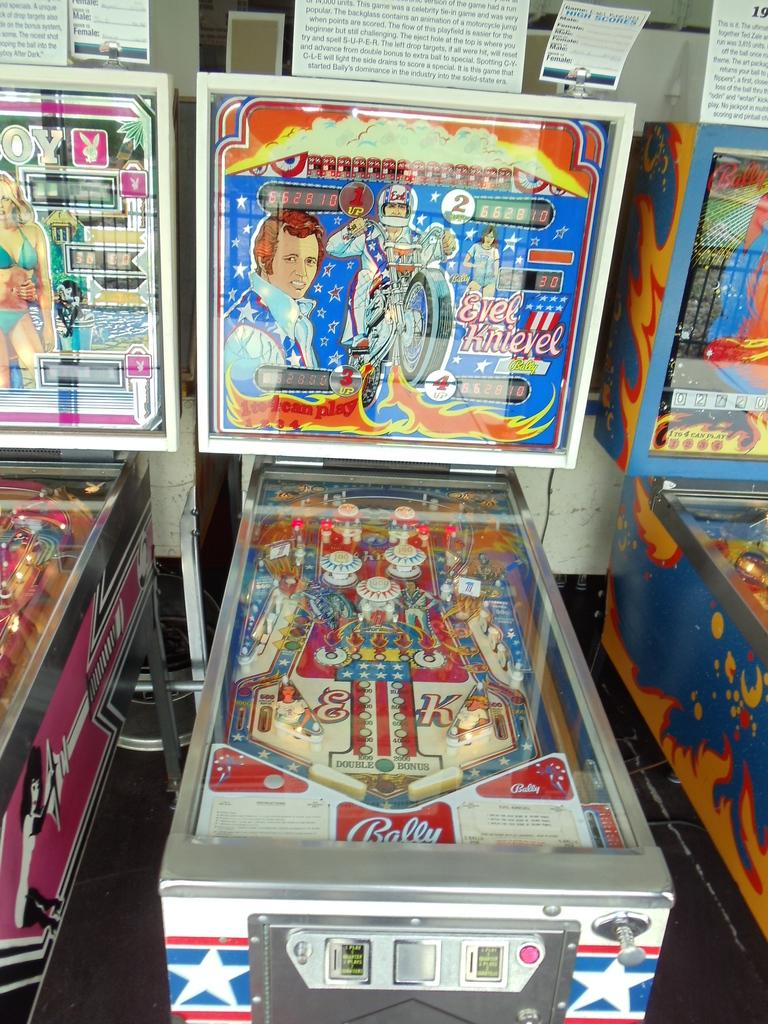<image>
Offer a succinct explanation of the picture presented. An Evel Knievel pinball machine, made by Bally, sits in a row of other pinball machines. 